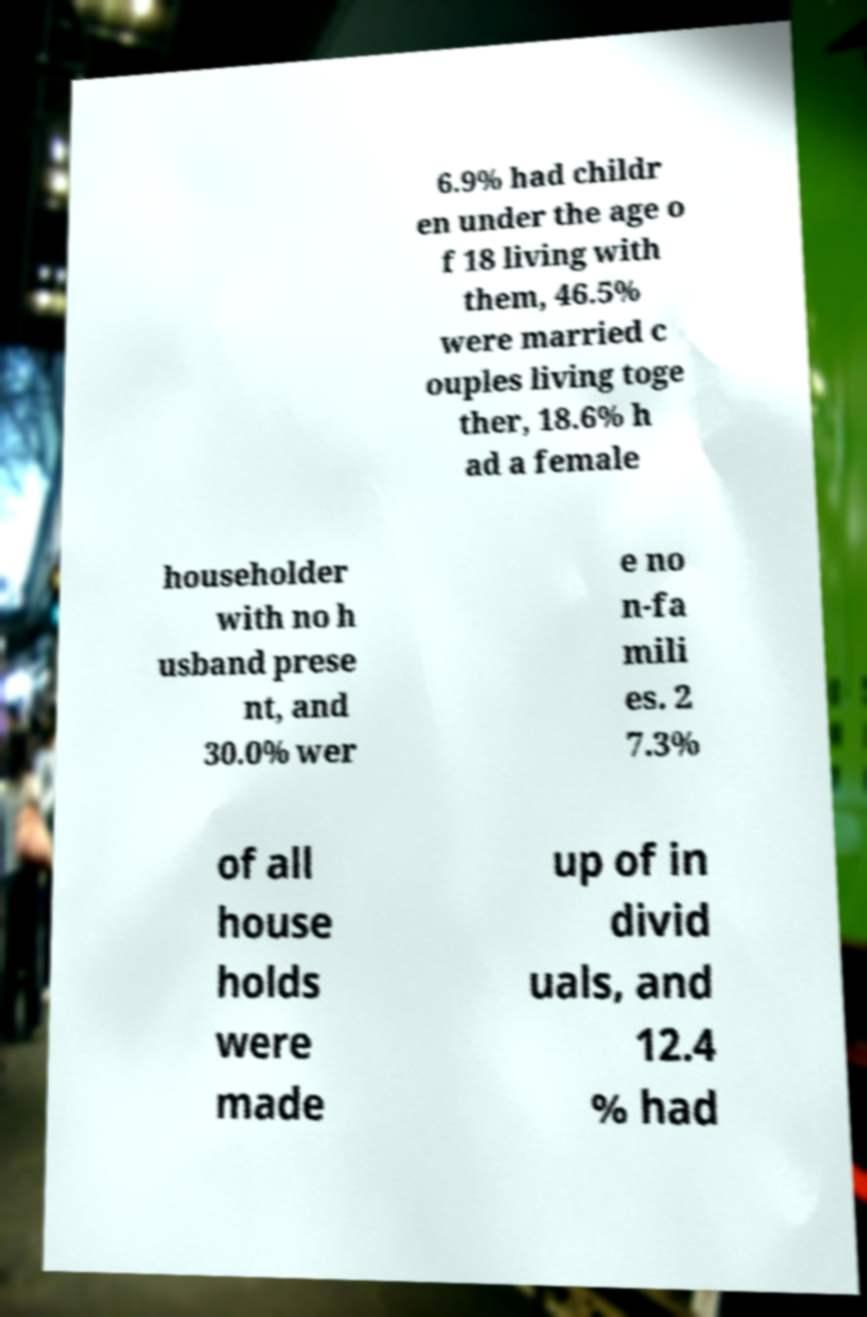I need the written content from this picture converted into text. Can you do that? 6.9% had childr en under the age o f 18 living with them, 46.5% were married c ouples living toge ther, 18.6% h ad a female householder with no h usband prese nt, and 30.0% wer e no n-fa mili es. 2 7.3% of all house holds were made up of in divid uals, and 12.4 % had 